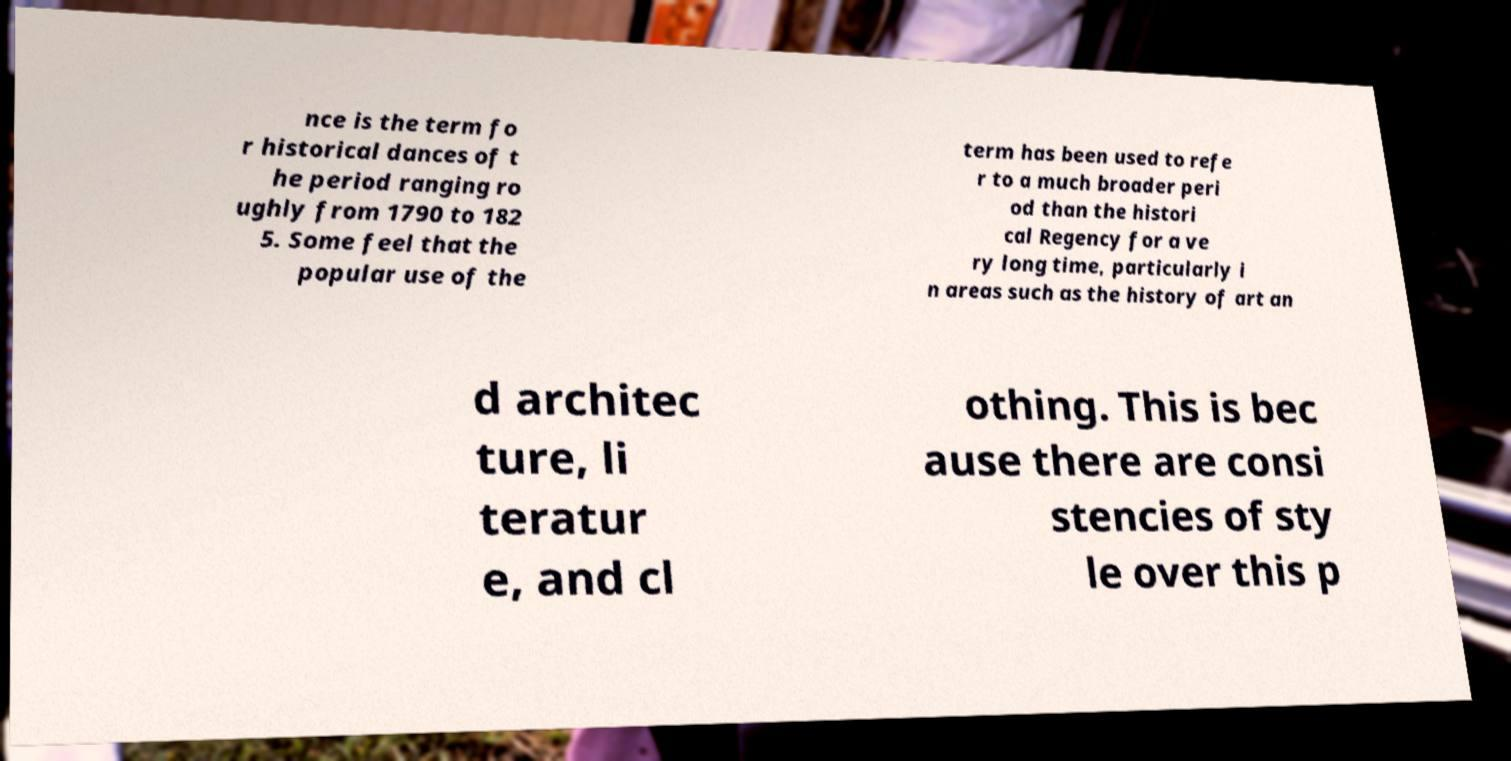What messages or text are displayed in this image? I need them in a readable, typed format. nce is the term fo r historical dances of t he period ranging ro ughly from 1790 to 182 5. Some feel that the popular use of the term has been used to refe r to a much broader peri od than the histori cal Regency for a ve ry long time, particularly i n areas such as the history of art an d architec ture, li teratur e, and cl othing. This is bec ause there are consi stencies of sty le over this p 